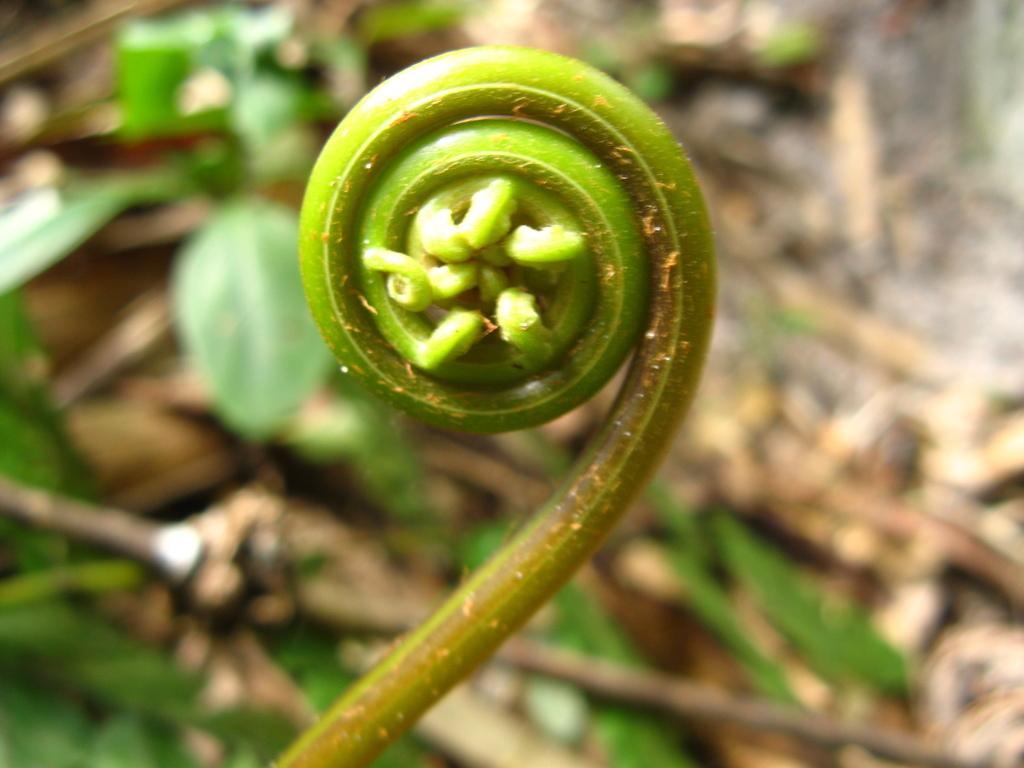What is the main subject of the image? There is a plant in the image. Can you describe the background of the image? The background of the image is blurry. What can be seen in the background of the image besides the blurry effect? There are leaves visible in the background of the image. What type of blade is being used to cut the rock in the image? There is no blade or rock present in the image; it features a plant and a blurry background with leaves. 